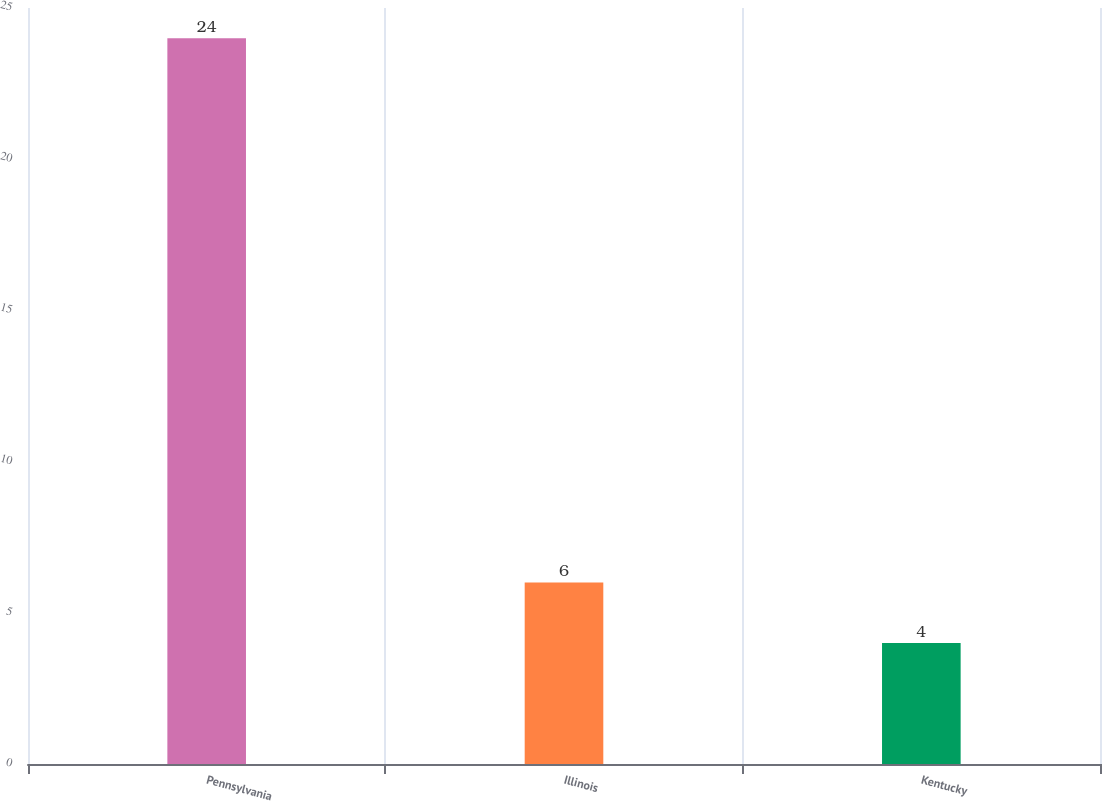<chart> <loc_0><loc_0><loc_500><loc_500><bar_chart><fcel>Pennsylvania<fcel>Illinois<fcel>Kentucky<nl><fcel>24<fcel>6<fcel>4<nl></chart> 